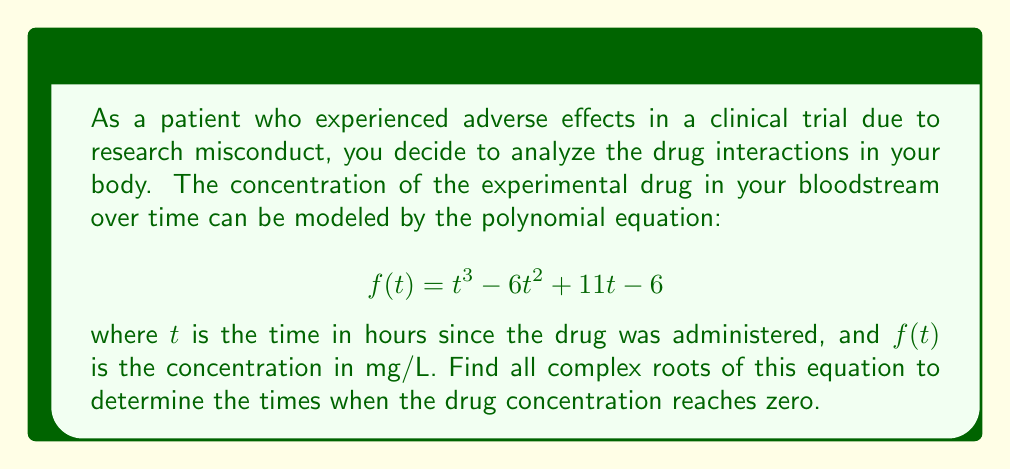Help me with this question. To find the roots of the polynomial equation $f(t) = t^3 - 6t^2 + 11t - 6$, we need to solve $f(t) = 0$. Let's approach this step-by-step:

1) First, we can try to factor out any obvious roots. Let's check if 1, 2, or 3 are roots:

   $f(1) = 1^3 - 6(1)^2 + 11(1) - 6 = 1 - 6 + 11 - 6 = 0$

   We found that 1 is a root. So we can factor out $(t-1)$:

   $t^3 - 6t^2 + 11t - 6 = (t-1)(t^2 - 5t + 6)$

2) Now we need to solve $t^2 - 5t + 6 = 0$. We can use the quadratic formula:

   $t = \frac{-b \pm \sqrt{b^2 - 4ac}}{2a}$

   where $a=1$, $b=-5$, and $c=6$

3) Substituting these values:

   $t = \frac{5 \pm \sqrt{25 - 24}}{2} = \frac{5 \pm 1}{2}$

4) This gives us two more roots:

   $t = \frac{5 + 1}{2} = 3$ and $t = \frac{5 - 1}{2} = 2$

Therefore, the three roots of the equation are 1, 2, and 3.
Answer: The roots of the equation $t^3 - 6t^2 + 11t - 6 = 0$ are $t = 1$, $t = 2$, and $t = 3$. 